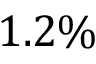Convert formula to latex. <formula><loc_0><loc_0><loc_500><loc_500>1 . 2 \%</formula> 